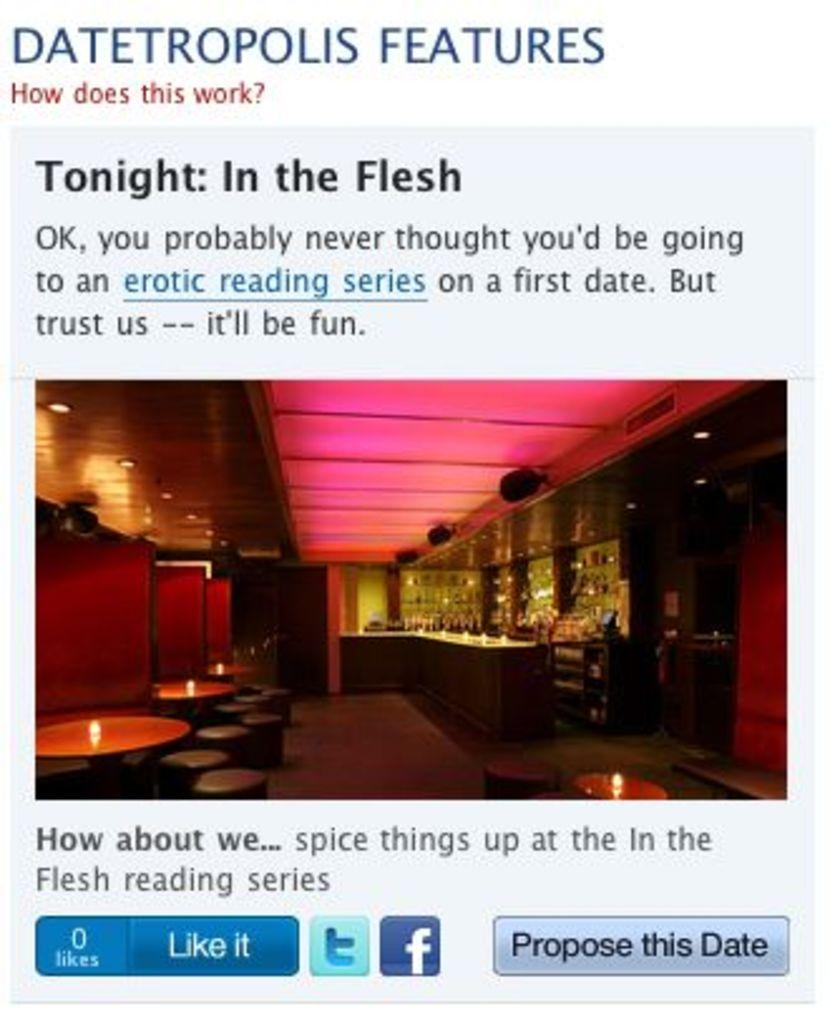What type of lighting is present in the image? There are electric lights and candles in the image. How are objects stored in the image? Objects are arranged in cupboards in the image. What type of furniture is visible for sitting? Seating stools are visible in the image. Where can text be found in the image? There is text at the top and bottom of the image. What type of punishment is being administered in the image? There is no indication of punishment in the image; it features electric lights, candles, cupboards, seating stools, and text. Who is giving their approval in the image? There is no indication of anyone giving approval in the image. 